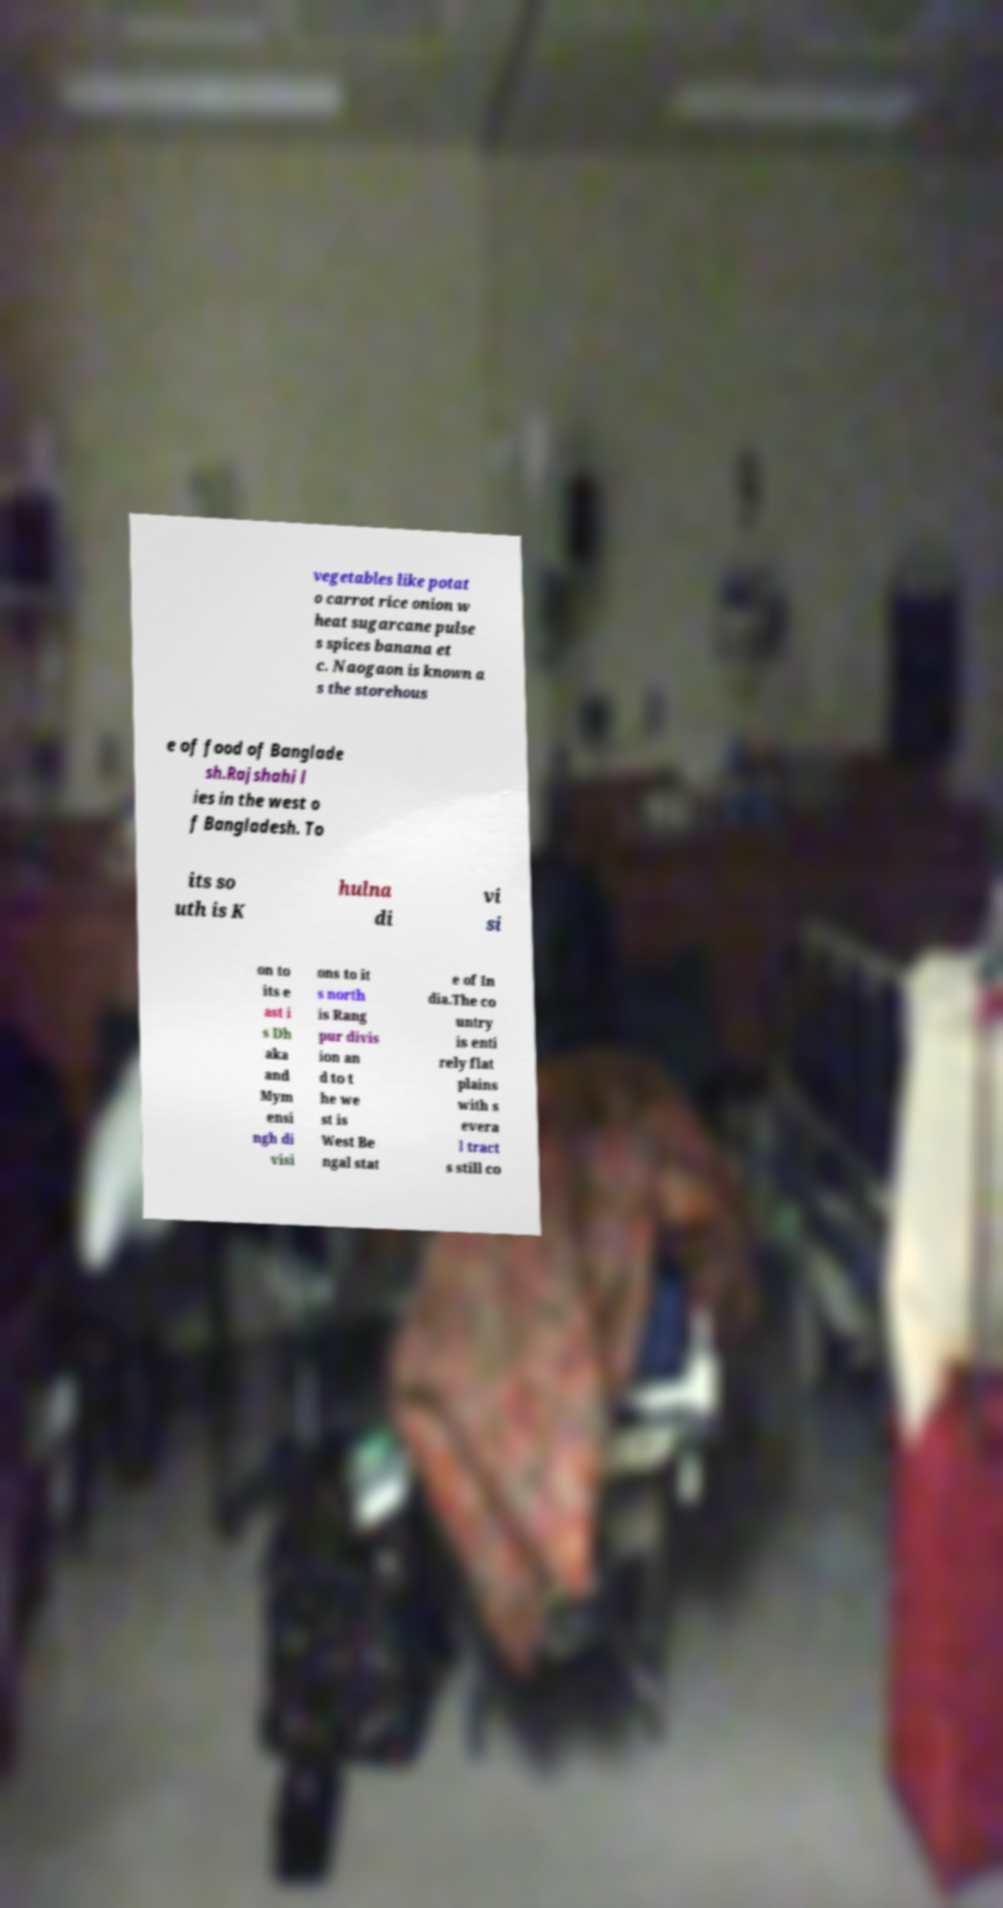There's text embedded in this image that I need extracted. Can you transcribe it verbatim? vegetables like potat o carrot rice onion w heat sugarcane pulse s spices banana et c. Naogaon is known a s the storehous e of food of Banglade sh.Rajshahi l ies in the west o f Bangladesh. To its so uth is K hulna di vi si on to its e ast i s Dh aka and Mym ensi ngh di visi ons to it s north is Rang pur divis ion an d to t he we st is West Be ngal stat e of In dia.The co untry is enti rely flat plains with s evera l tract s still co 